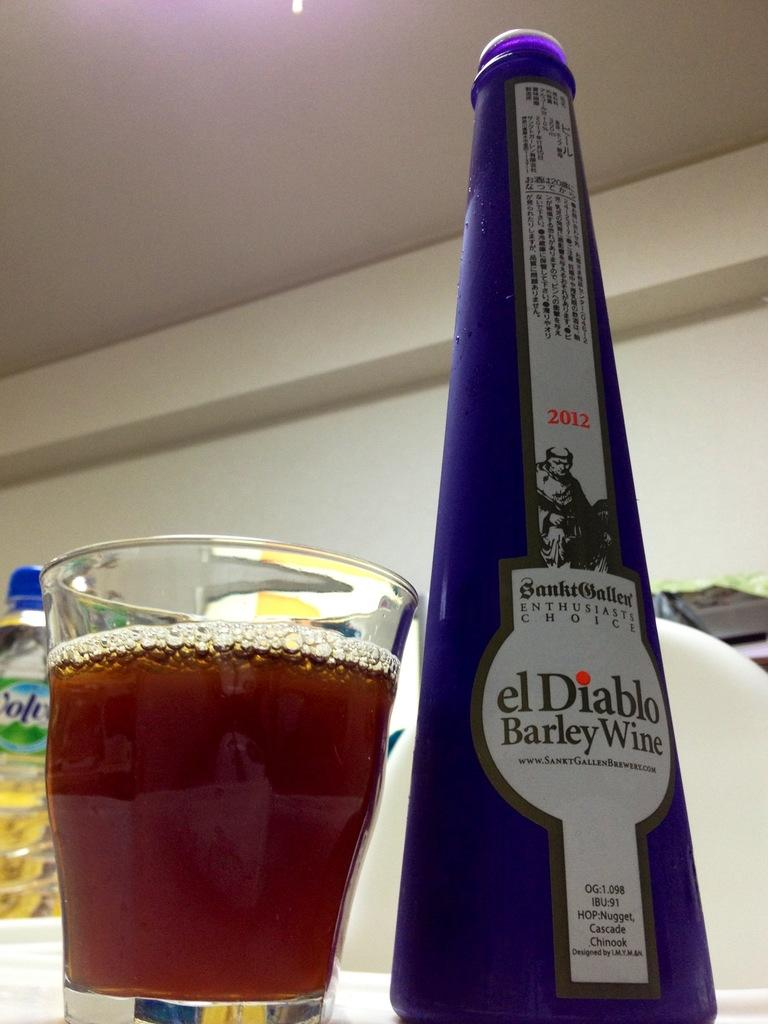<image>
Summarize the visual content of the image. A glass filled with El Diablo barley wine sits next to its bottle. 